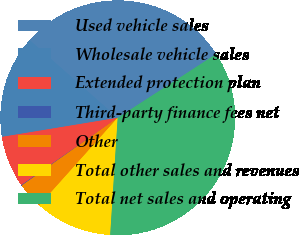Convert chart to OTSL. <chart><loc_0><loc_0><loc_500><loc_500><pie_chart><fcel>Used vehicle sales<fcel>Wholesale vehicle sales<fcel>Extended protection plan<fcel>Third-party finance fees net<fcel>Other<fcel>Total other sales and revenues<fcel>Total net sales and operating<nl><fcel>29.35%<fcel>14.11%<fcel>7.1%<fcel>0.08%<fcel>3.59%<fcel>10.61%<fcel>35.16%<nl></chart> 